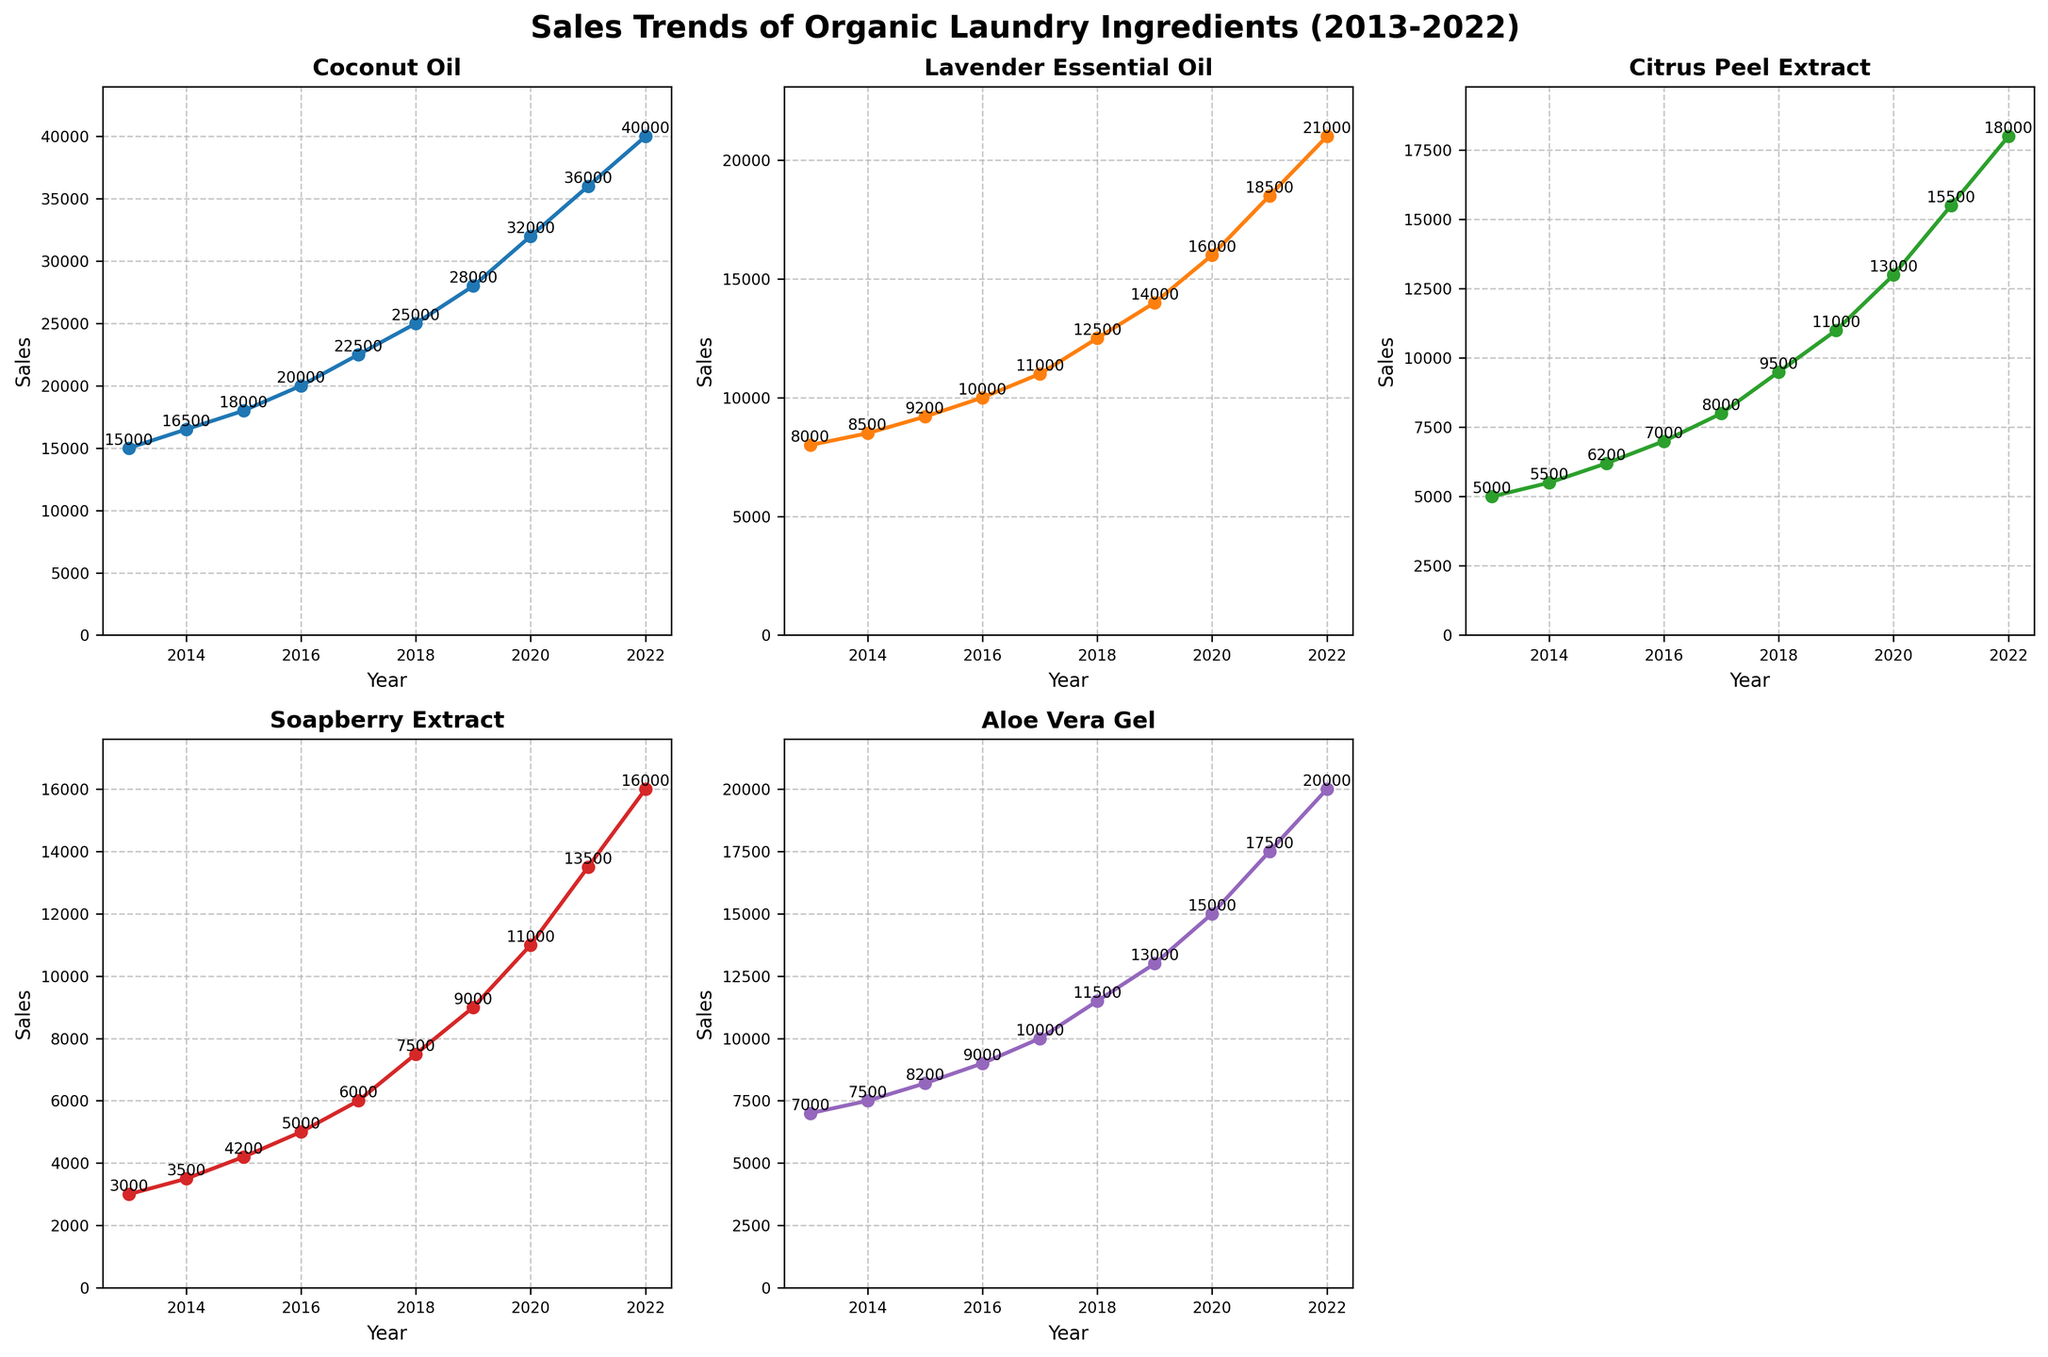what is the title of the figure? The title is displayed prominently at the top of the figure in larger, bold font. It provides a summary of what the figure represents.
Answer: Sales Trends of Organic Laundry Ingredients (2013-2022) How many product types are shown in the figure? Each subplot represents a different product type, and there are 5 subplots with actual data.
Answer: 5 Which product had the highest sales in 2022? By examining the 2022 data point in each subplot, the product with the highest sales can be identified.
Answer: Coconut Oil What was the sales difference between Aloe Vera Gel and Soapberry Extract in 2020? Look at the 2020 sales data for Aloe Vera Gel and Soapberry Extract, then subtract the smaller value from the larger value. Sales of Aloe Vera Gel was 15000 and Soapberry Extract was 11000.
Answer: 4000 Which years show a crossover where one product's sales exceed another previously higher-selling product for the first time? Observe where the lines cross each other in adjacent subplots. For instance, if one line starts below another and crosses it as time progresses.
Answer: No crossovers observed What is the average sales trend for Citrus Peel Extract over the years? Add all the sales values for Citrus Peel Extract from 2013 to 2022 and divide by the number of years (10). Summing these values yields 101200; dividing by 10 gives 10120.
Answer: 10120 In what year did Coconut Oil first sell more than 20000 units? Find the point in the Coconut Oil subplot where the sales data line first exceeds 20000 units and note the corresponding year.
Answer: 2016 Which product experienced the greatest growth in sales from 2013 to 2022? Calculate the difference in sales from 2013 to 2022 for each product and compare these values. Coconut Oil grew from 15000 to 40000, which is the greatest increase (25000).
Answer: Coconut Oil By what percentage did Lavender Essential Oil sales increase from 2015 to 2019? Calculate the percentage increase using the formula: ((Sales in 2019 - Sales in 2015)/Sales in 2015) * 100. This is ((14000-9200)/9200) * 100 = 52.17%.
Answer: 52.17% What is common about the sales trends of all products? Identify any general patterns or trends shared among all subplots, like uniform increases or decreases. All product sales trends show a consistent increase over the years.
Answer: Consistent increase 